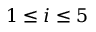Convert formula to latex. <formula><loc_0><loc_0><loc_500><loc_500>1 \leq i \leq 5</formula> 